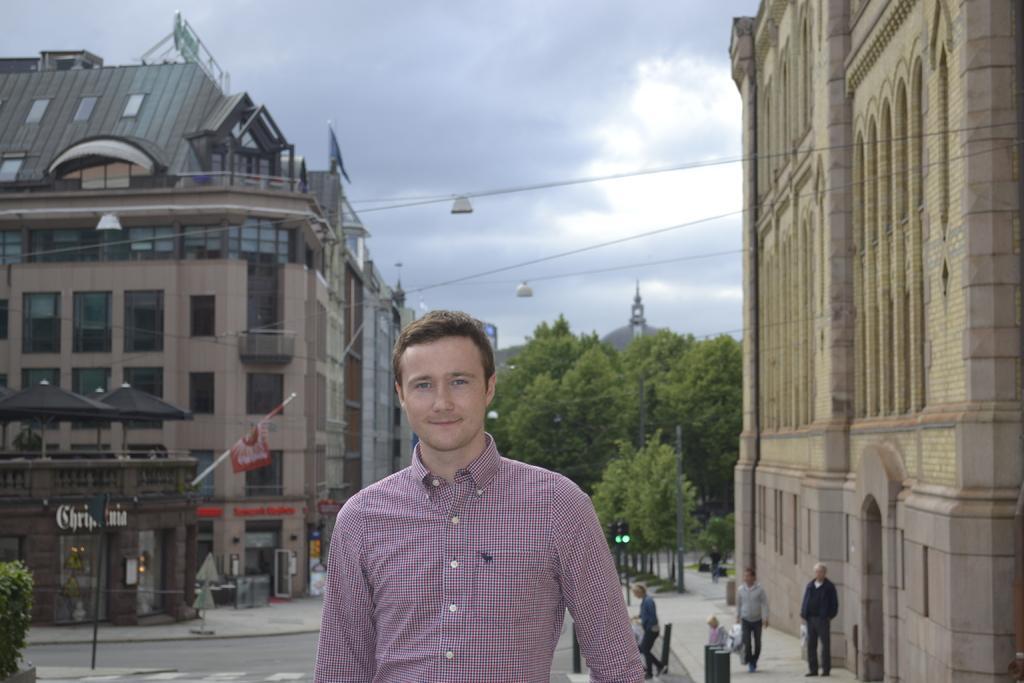Can you describe this image briefly? In this picture we can see a man smiling and at the back of him we can see the road, some people, poles, flag, trees, traffic signals, buildings with windows and some objects and in the background we can see the sky. 